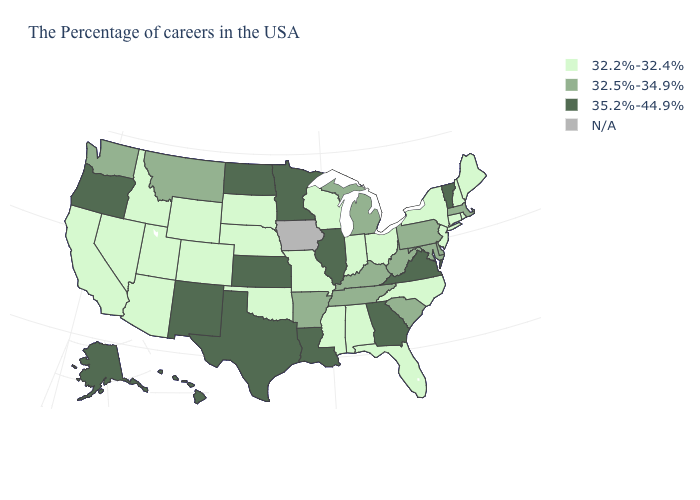What is the value of New Hampshire?
Concise answer only. 32.2%-32.4%. What is the value of Pennsylvania?
Give a very brief answer. 32.5%-34.9%. Name the states that have a value in the range 32.5%-34.9%?
Answer briefly. Massachusetts, Delaware, Maryland, Pennsylvania, South Carolina, West Virginia, Michigan, Kentucky, Tennessee, Arkansas, Montana, Washington. What is the value of Alaska?
Write a very short answer. 35.2%-44.9%. Which states hav the highest value in the West?
Short answer required. New Mexico, Oregon, Alaska, Hawaii. Among the states that border Rhode Island , does Massachusetts have the lowest value?
Write a very short answer. No. What is the value of Alaska?
Short answer required. 35.2%-44.9%. What is the value of Tennessee?
Concise answer only. 32.5%-34.9%. Among the states that border Missouri , does Oklahoma have the lowest value?
Short answer required. Yes. What is the value of Minnesota?
Short answer required. 35.2%-44.9%. Name the states that have a value in the range 35.2%-44.9%?
Answer briefly. Vermont, Virginia, Georgia, Illinois, Louisiana, Minnesota, Kansas, Texas, North Dakota, New Mexico, Oregon, Alaska, Hawaii. Name the states that have a value in the range N/A?
Short answer required. Iowa. 